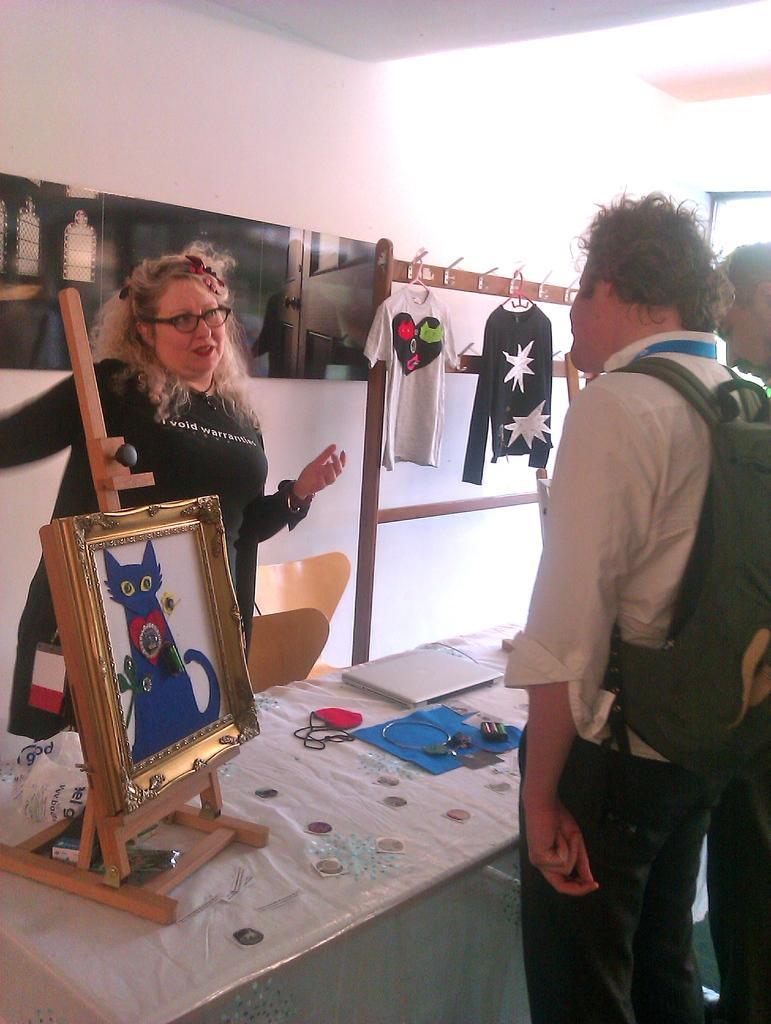Please provide a concise description of this image. In this picture we can see two persons standing on the floor. This is table. On the table there is a frame. On the background there is a wall. And these are the t shirts. 